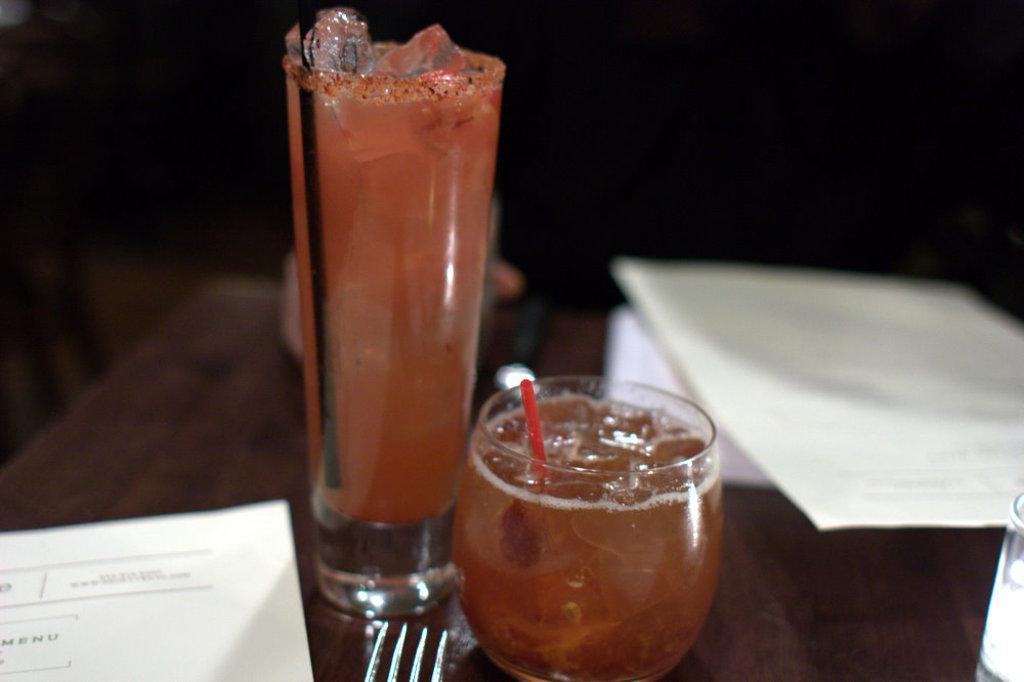In one or two sentences, can you explain what this image depicts? This image consists of a table. On that there are papers, glasses, forks. 